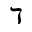<formula> <loc_0><loc_0><loc_500><loc_500>\daleth</formula> 